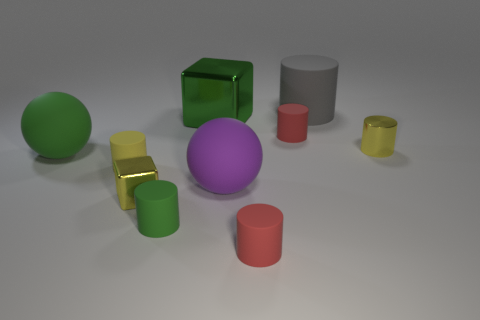Subtract all gray cylinders. How many cylinders are left? 5 Subtract all tiny metal cylinders. How many cylinders are left? 5 Subtract all brown cylinders. Subtract all purple cubes. How many cylinders are left? 6 Subtract all cylinders. How many objects are left? 4 Add 8 big purple matte things. How many big purple matte things exist? 9 Subtract 0 gray spheres. How many objects are left? 10 Subtract all big green things. Subtract all green shiny objects. How many objects are left? 7 Add 4 tiny red matte things. How many tiny red matte things are left? 6 